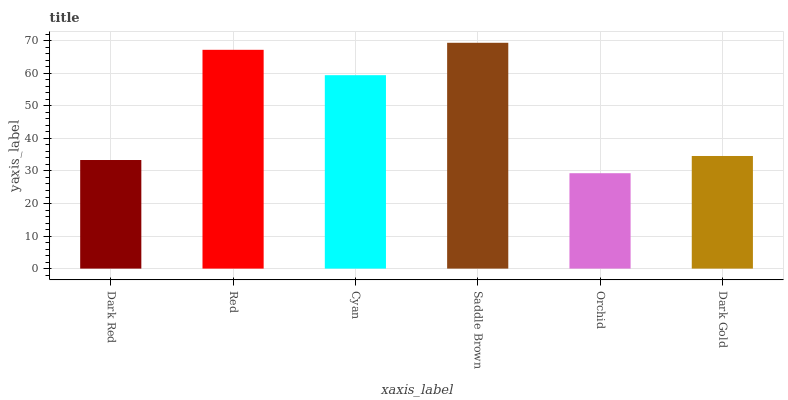Is Orchid the minimum?
Answer yes or no. Yes. Is Saddle Brown the maximum?
Answer yes or no. Yes. Is Red the minimum?
Answer yes or no. No. Is Red the maximum?
Answer yes or no. No. Is Red greater than Dark Red?
Answer yes or no. Yes. Is Dark Red less than Red?
Answer yes or no. Yes. Is Dark Red greater than Red?
Answer yes or no. No. Is Red less than Dark Red?
Answer yes or no. No. Is Cyan the high median?
Answer yes or no. Yes. Is Dark Gold the low median?
Answer yes or no. Yes. Is Dark Red the high median?
Answer yes or no. No. Is Cyan the low median?
Answer yes or no. No. 